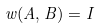<formula> <loc_0><loc_0><loc_500><loc_500>w ( A , B ) = I</formula> 